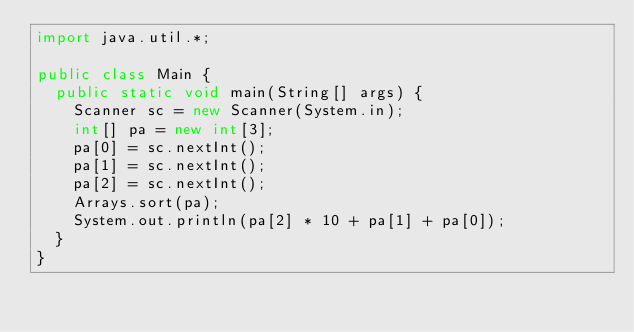<code> <loc_0><loc_0><loc_500><loc_500><_Java_>import java.util.*;

public class Main {
  public static void main(String[] args) {
    Scanner sc = new Scanner(System.in);
    int[] pa = new int[3];
    pa[0] = sc.nextInt();
    pa[1] = sc.nextInt();
    pa[2] = sc.nextInt();
    Arrays.sort(pa);
    System.out.println(pa[2] * 10 + pa[1] + pa[0]);
  }
}</code> 